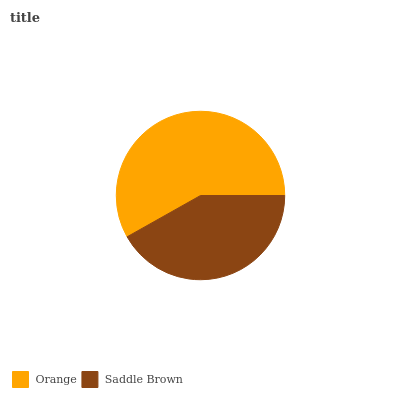Is Saddle Brown the minimum?
Answer yes or no. Yes. Is Orange the maximum?
Answer yes or no. Yes. Is Saddle Brown the maximum?
Answer yes or no. No. Is Orange greater than Saddle Brown?
Answer yes or no. Yes. Is Saddle Brown less than Orange?
Answer yes or no. Yes. Is Saddle Brown greater than Orange?
Answer yes or no. No. Is Orange less than Saddle Brown?
Answer yes or no. No. Is Orange the high median?
Answer yes or no. Yes. Is Saddle Brown the low median?
Answer yes or no. Yes. Is Saddle Brown the high median?
Answer yes or no. No. Is Orange the low median?
Answer yes or no. No. 